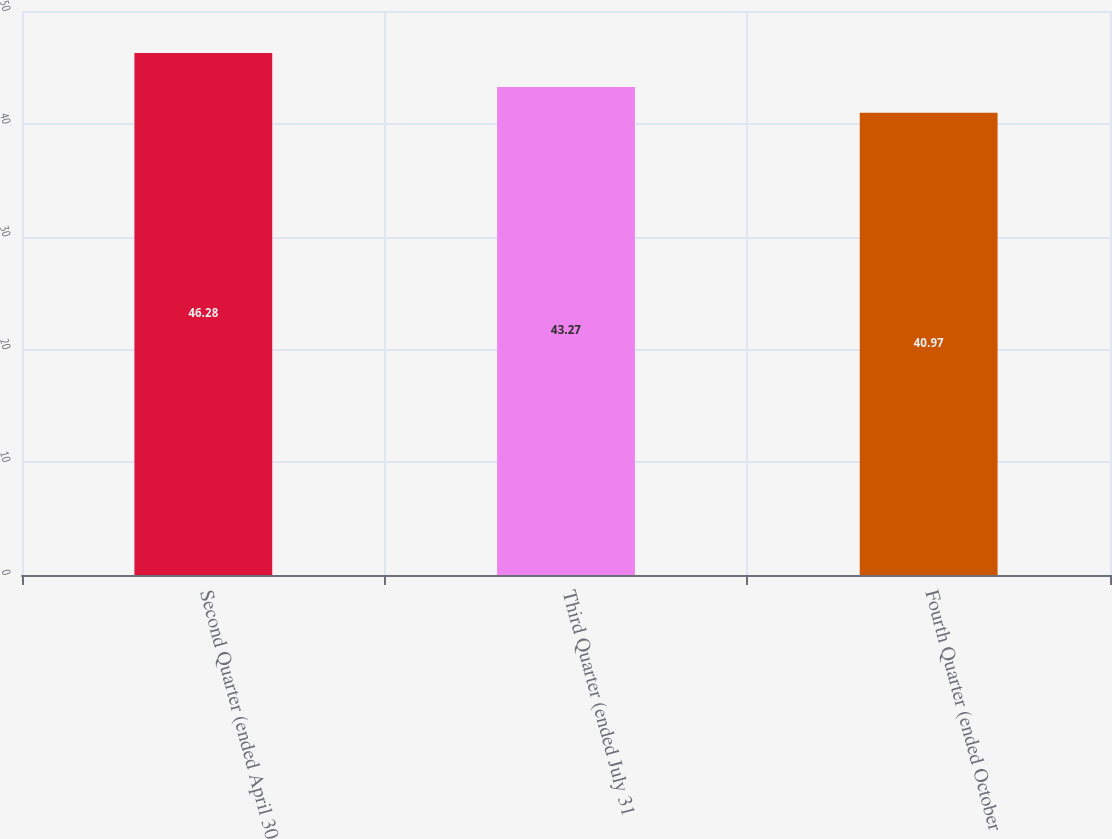Convert chart to OTSL. <chart><loc_0><loc_0><loc_500><loc_500><bar_chart><fcel>Second Quarter (ended April 30<fcel>Third Quarter (ended July 31<fcel>Fourth Quarter (ended October<nl><fcel>46.28<fcel>43.27<fcel>40.97<nl></chart> 